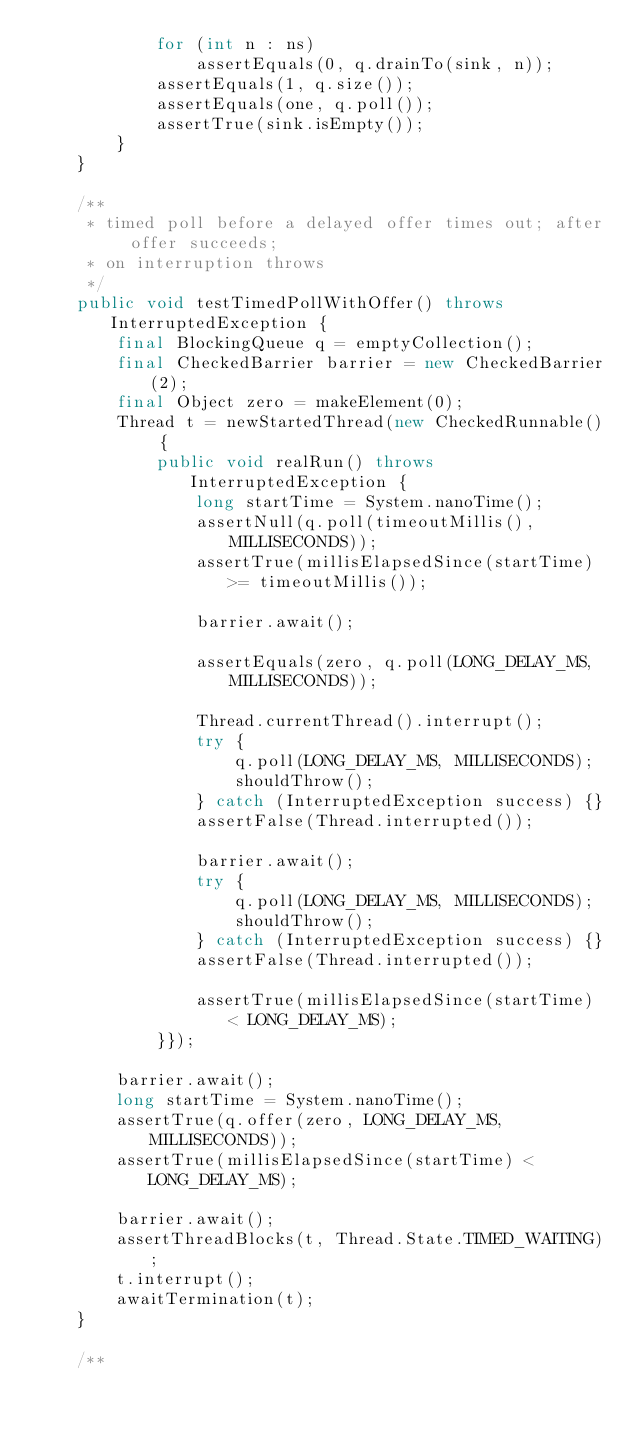Convert code to text. <code><loc_0><loc_0><loc_500><loc_500><_Java_>            for (int n : ns)
                assertEquals(0, q.drainTo(sink, n));
            assertEquals(1, q.size());
            assertEquals(one, q.poll());
            assertTrue(sink.isEmpty());
        }
    }

    /**
     * timed poll before a delayed offer times out; after offer succeeds;
     * on interruption throws
     */
    public void testTimedPollWithOffer() throws InterruptedException {
        final BlockingQueue q = emptyCollection();
        final CheckedBarrier barrier = new CheckedBarrier(2);
        final Object zero = makeElement(0);
        Thread t = newStartedThread(new CheckedRunnable() {
            public void realRun() throws InterruptedException {
                long startTime = System.nanoTime();
                assertNull(q.poll(timeoutMillis(), MILLISECONDS));
                assertTrue(millisElapsedSince(startTime) >= timeoutMillis());

                barrier.await();

                assertEquals(zero, q.poll(LONG_DELAY_MS, MILLISECONDS));

                Thread.currentThread().interrupt();
                try {
                    q.poll(LONG_DELAY_MS, MILLISECONDS);
                    shouldThrow();
                } catch (InterruptedException success) {}
                assertFalse(Thread.interrupted());

                barrier.await();
                try {
                    q.poll(LONG_DELAY_MS, MILLISECONDS);
                    shouldThrow();
                } catch (InterruptedException success) {}
                assertFalse(Thread.interrupted());

                assertTrue(millisElapsedSince(startTime) < LONG_DELAY_MS);
            }});

        barrier.await();
        long startTime = System.nanoTime();
        assertTrue(q.offer(zero, LONG_DELAY_MS, MILLISECONDS));
        assertTrue(millisElapsedSince(startTime) < LONG_DELAY_MS);

        barrier.await();
        assertThreadBlocks(t, Thread.State.TIMED_WAITING);
        t.interrupt();
        awaitTermination(t);
    }

    /**</code> 